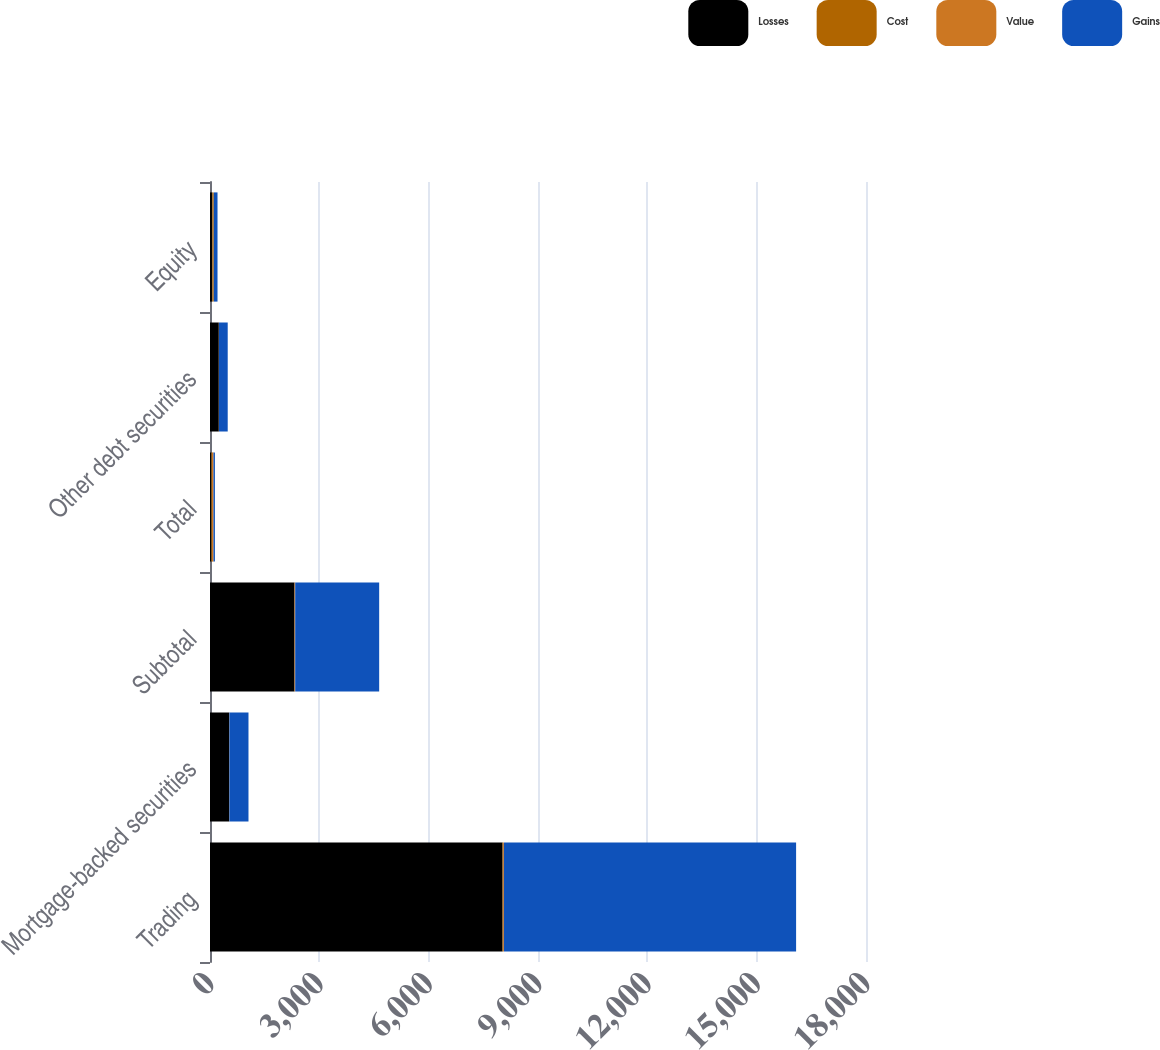Convert chart to OTSL. <chart><loc_0><loc_0><loc_500><loc_500><stacked_bar_chart><ecel><fcel>Trading<fcel>Mortgage-backed securities<fcel>Subtotal<fcel>Total<fcel>Other debt securities<fcel>Equity<nl><fcel>Losses<fcel>8028<fcel>527<fcel>2319<fcel>39.5<fcel>242<fcel>65<nl><fcel>Cost<fcel>13<fcel>1<fcel>2<fcel>15<fcel>1<fcel>38<nl><fcel>Value<fcel>24<fcel>4<fcel>17<fcel>41<fcel>3<fcel>1<nl><fcel>Gains<fcel>8017<fcel>524<fcel>2304<fcel>39.5<fcel>240<fcel>102<nl></chart> 